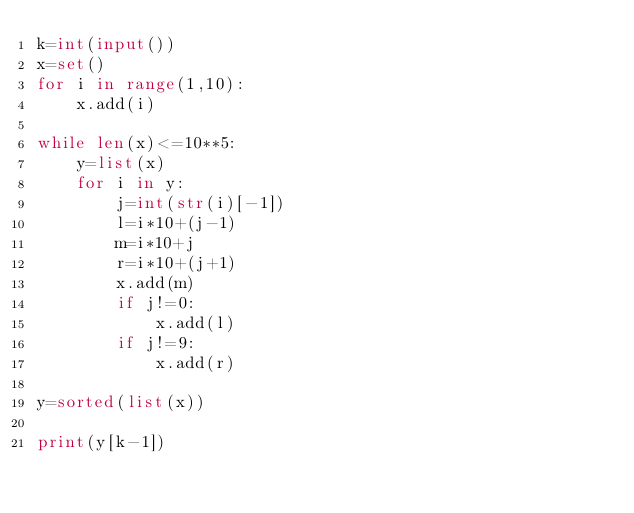Convert code to text. <code><loc_0><loc_0><loc_500><loc_500><_Python_>k=int(input())
x=set()
for i in range(1,10):
	x.add(i)

while len(x)<=10**5:
	y=list(x)
	for i in y:
		j=int(str(i)[-1])
		l=i*10+(j-1)
		m=i*10+j
		r=i*10+(j+1)
		x.add(m)
		if j!=0:
			x.add(l)
		if j!=9:
			x.add(r)

y=sorted(list(x))

print(y[k-1])</code> 